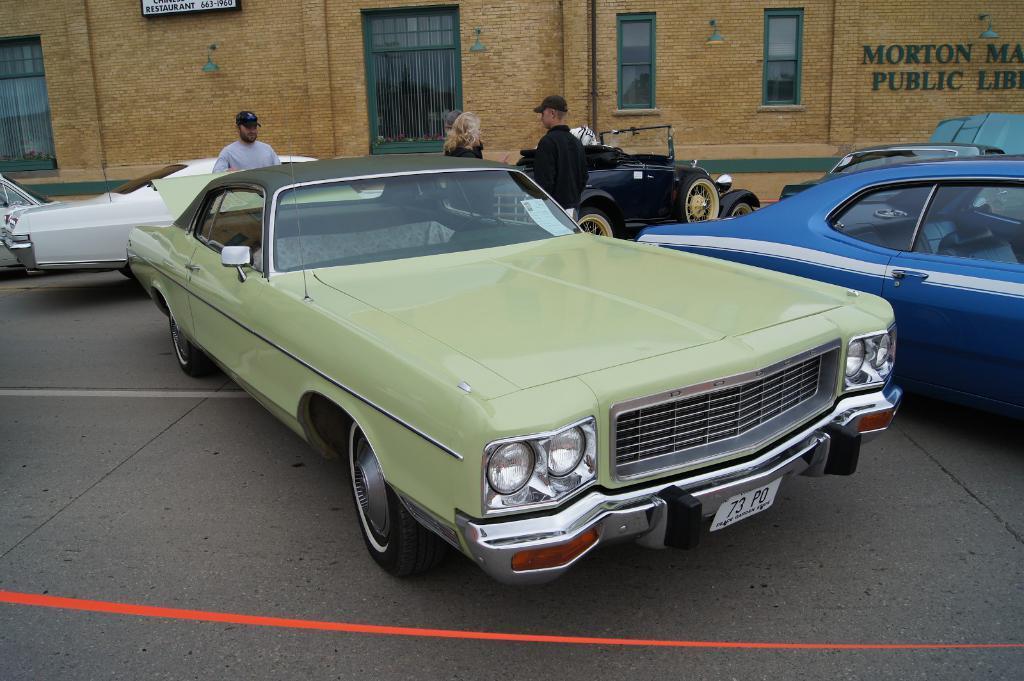In one or two sentences, can you explain what this image depicts? In this image we can see some cars parked on the road. We can also see some people standing beside them. On the backside we can see a building with windows, sign board, street lamps and a board. 